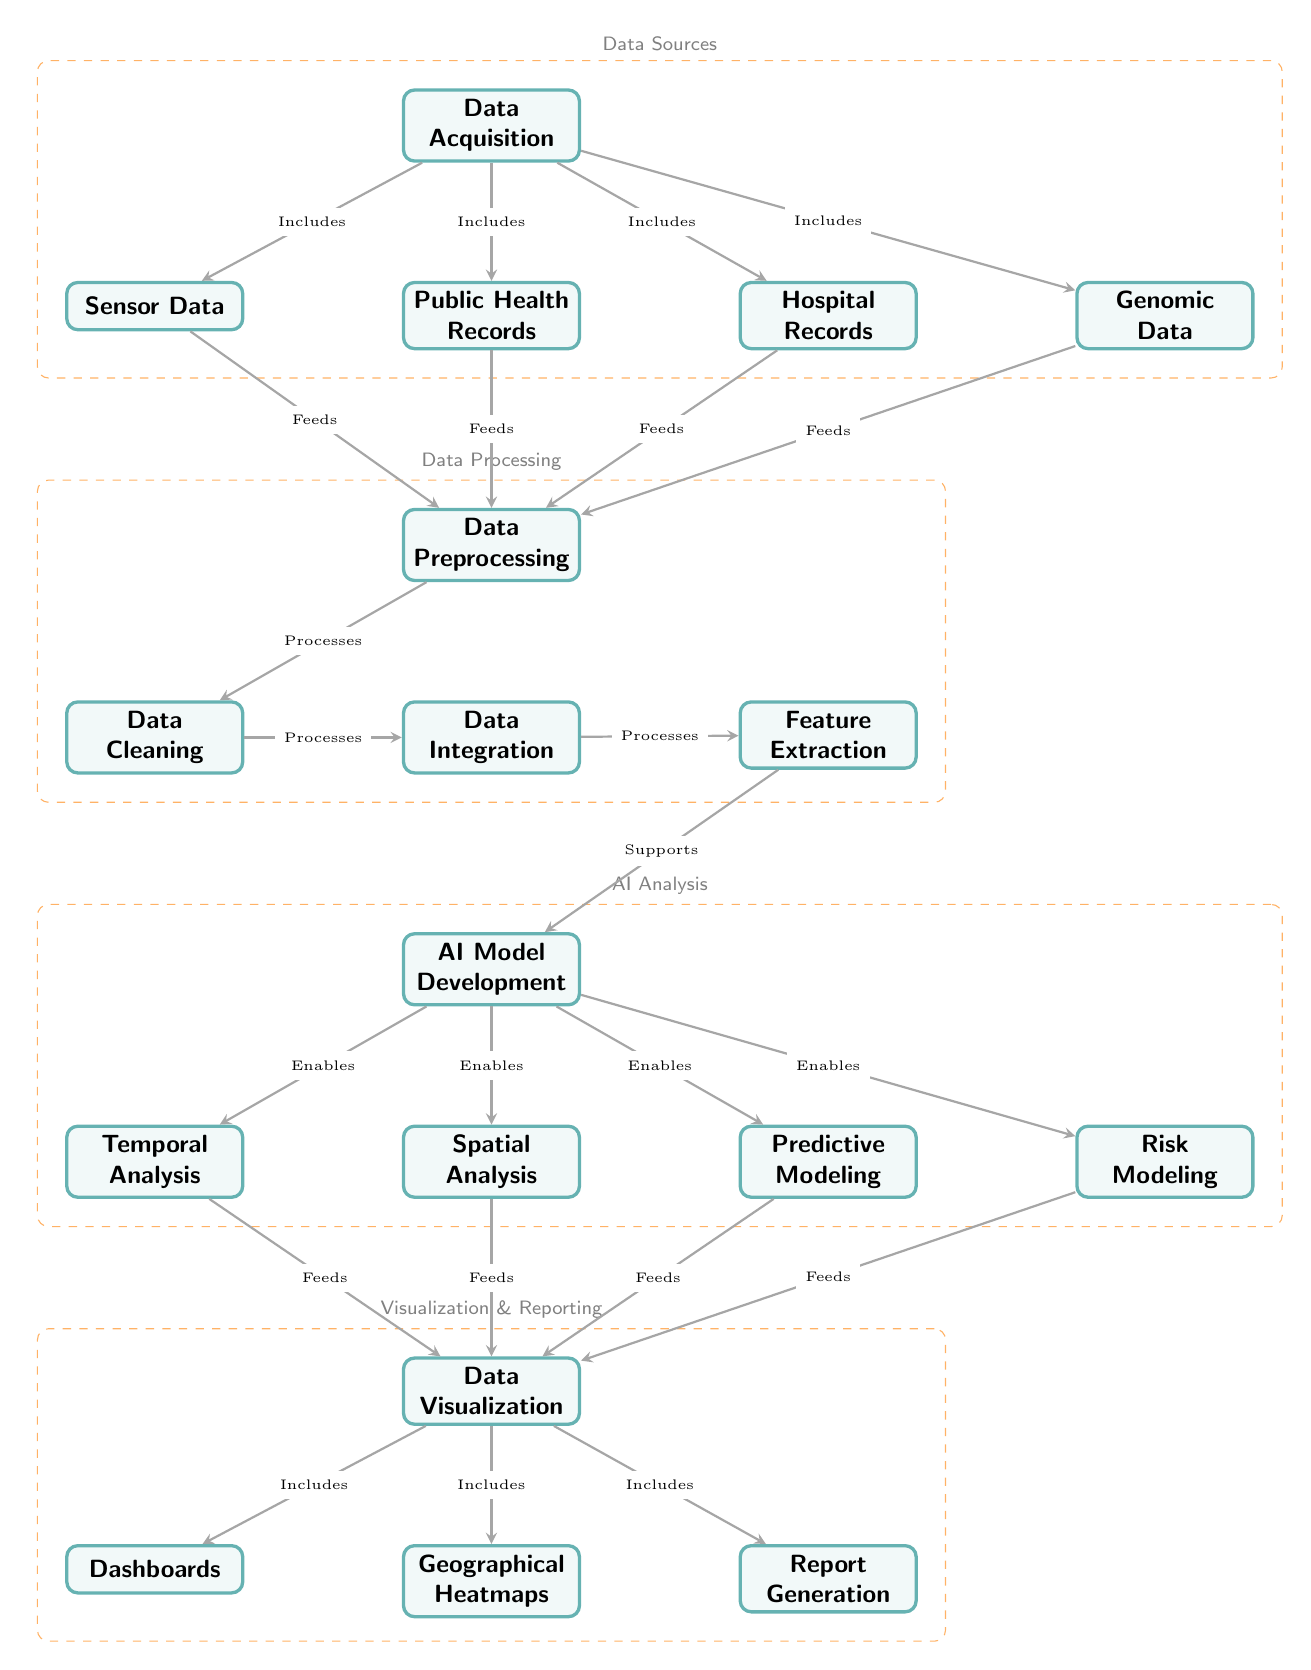What are the four main categories represented in the diagram? The diagram is divided into four main categories: Data Sources, Data Processing, AI Analysis, and Visualization & Reporting. These categories are indicated by the dashed group boxes that visually group related nodes.
Answer: Data Sources, Data Processing, AI Analysis, Visualization & Reporting How many nodes are in the 'AI Analysis' category? In the 'AI Analysis' category, there are four nodes: AI Model Development, Temporal Analysis, Spatial Analysis, and Predictive Modeling. This is confirmed by counting the nodes within the dashed group box labeled 'AI Analysis' on the diagram.
Answer: Four Which node feeds into the 'Data Preprocessing' node? The nodes that feed into the 'Data Preprocessing' node are Sensor Data, Public Health Records, Hospital Records, and Genomic Data. These relationships are indicated by the directed edges from each of these nodes leading to 'Data Preprocessing'.
Answer: Sensor Data, Public Health Records, Hospital Records, Genomic Data What is the role of the 'Feature Extraction' node? The 'Feature Extraction' node supports the 'AI Model Development' node by processing the integrated data, as indicated by the directed edge showing this relationship. This step involves extracting relevant features for the AI analysis.
Answer: Supports AI Model Development Which nodes are included in the 'Visualization & Reporting' category? The 'Visualization & Reporting' category includes three nodes: Dashboards, Geographical Heatmaps, and Report Generation. This is clearly demarcated by the dashed group box that encompasses these nodes in the diagram.
Answer: Dashboards, Geographical Heatmaps, Report Generation What type of data is the 'Temporal Analysis' node involved with? The 'Temporal Analysis' node is involved with data collected over time and is fed by the output of the 'AI Model Development', indicating its role in analyzing trends and patterns related to time in the underlying data.
Answer: Time-related data What processes are involved in moving from 'Data Cleaning' to 'Feature Extraction'? The movement from 'Data Cleaning' to 'Feature Extraction' involves two main processes: Data Cleaning processes data into Data Integration, which then undergoes Feature Extraction. This shows a sequential flow of data processing.
Answer: Data Cleaning, Data Integration, Feature Extraction Which nodes enable the 'Risk Modeling' node? The nodes that enable the 'Risk Modeling' node are Temporal Analysis, Spatial Analysis, and Predictive Modeling. These nodes provide the necessary analytical capabilities to assess risks based on the processed data.
Answer: Temporal Analysis, Spatial Analysis, Predictive Modeling 